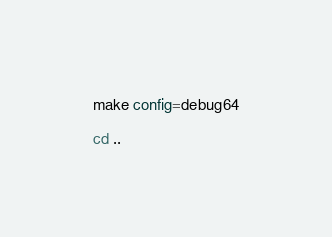Convert code to text. <code><loc_0><loc_0><loc_500><loc_500><_Bash_>make config=debug64

cd ..
</code> 